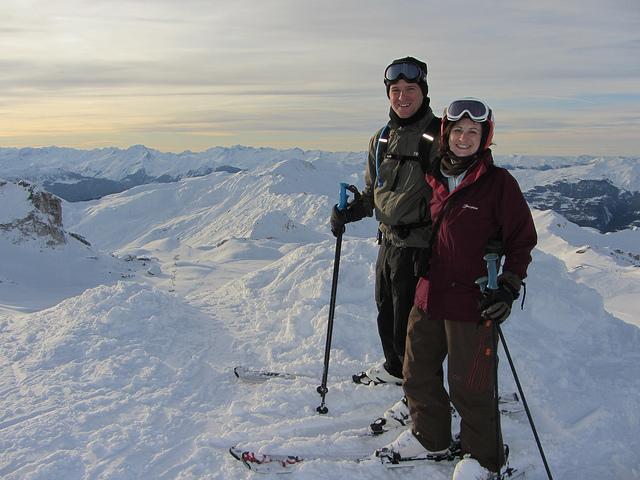How many poles is she holding?
Give a very brief answer. 1. How many people can be seen?
Give a very brief answer. 2. How many cars are on the right of the horses and riders?
Give a very brief answer. 0. 